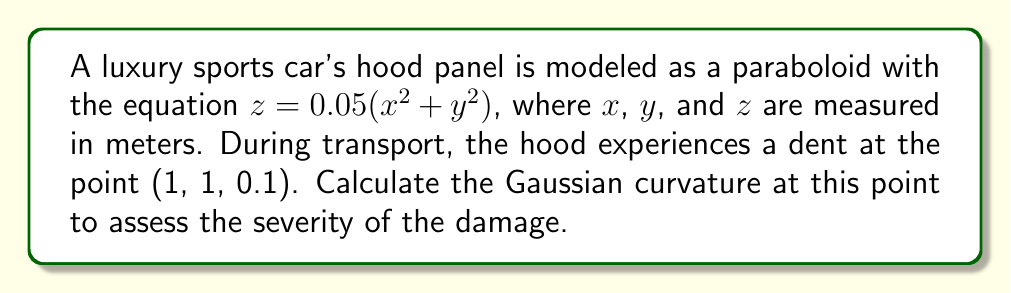Show me your answer to this math problem. To calculate the Gaussian curvature of the paraboloid at the given point, we'll follow these steps:

1. The paraboloid is given by the equation:
   $$z = 0.05(x^2 + y^2)$$

2. We need to calculate the partial derivatives:
   $$z_x = 0.1x$$
   $$z_y = 0.1y$$
   $$z_{xx} = 0.1$$
   $$z_{yy} = 0.1$$
   $$z_{xy} = 0$$

3. The Gaussian curvature K is given by the formula:
   $$K = \frac{z_{xx}z_{yy} - z_{xy}^2}{(1 + z_x^2 + z_y^2)^2}$$

4. At the point (1, 1, 0.1), we have:
   $$z_x = 0.1$$
   $$z_y = 0.1$$
   $$z_{xx} = 0.1$$
   $$z_{yy} = 0.1$$
   $$z_{xy} = 0$$

5. Substituting these values into the formula:
   $$K = \frac{(0.1)(0.1) - 0^2}{(1 + 0.1^2 + 0.1^2)^2}$$

6. Simplifying:
   $$K = \frac{0.01}{(1 + 0.02)^2} = \frac{0.01}{1.0404} \approx 0.00961$$

The Gaussian curvature at the point (1, 1, 0.1) is approximately 0.00961 m^(-2).
Answer: $0.00961 \text{ m}^{-2}$ 